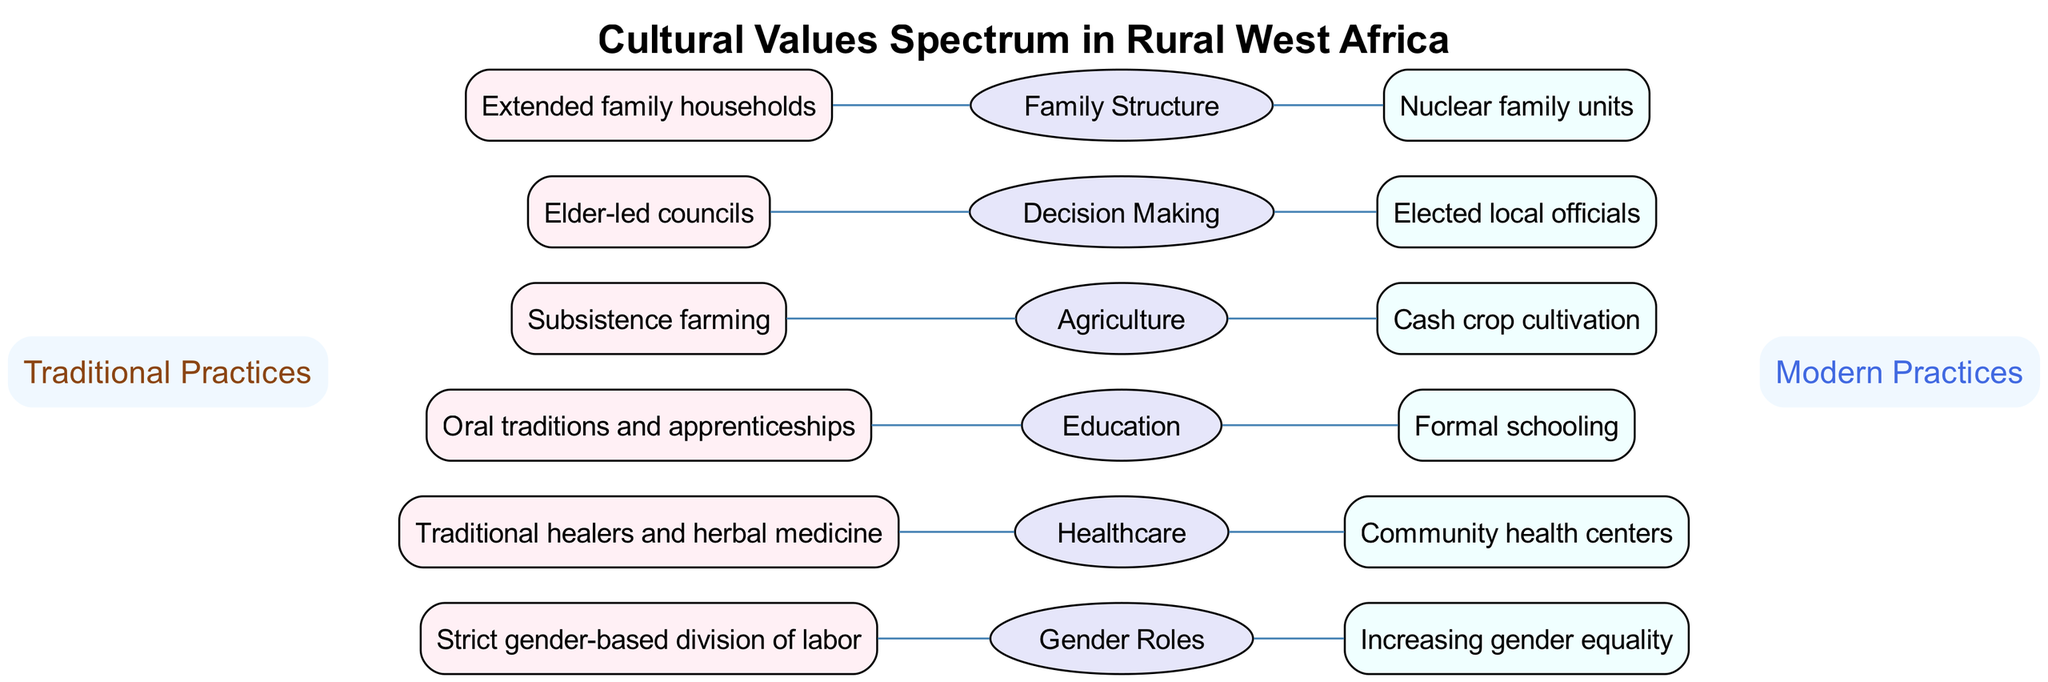What is the traditional family structure depicted in the diagram? The diagram states that the traditional family structure is "Extended family households." This information can be found in the category labeled "Family Structure," where the left side (traditional) gives this value.
Answer: Extended family households What is the modern practice for education according to the diagram? In the "Education" category of the diagram, it shows that the modern practice is "Formal schooling," which is indicated on the right side text for that specific category.
Answer: Formal schooling How many categories are present in the diagram? The diagram lists a total of six categories: "Family Structure," "Decision Making," "Agriculture," "Education," "Healthcare," and "Gender Roles." Counting these gives a total of six categories.
Answer: 6 Which decision-making practice is considered traditional? In the category labeled "Decision Making," the diagram indicates that the traditional practice is "Elder-led councils." This is found on the left side of that category.
Answer: Elder-led councils Which healthcare practice is modern in the diagram? The "Healthcare" category shows that the modern practice is "Community health centers." This information is located on the right side of the healthcare category in the diagram.
Answer: Community health centers What is the relationship between traditional healers and modern healthcare? Traditional healers are grouped with "Traditional healers and herbal medicine" in the "Healthcare" category, while "Community health centers" is positioned on the modern side. The relationship indicates a shift from traditional methods to modern healthcare solutions.
Answer: Shift from traditional to modern What is the main difference in gender roles expressed in the diagram? The diagram showcases a clear distinction: on the traditional side, it states "Strict gender-based division of labor," while the modern side represents "Increasing gender equality." This reflects a transition in gender roles over time.
Answer: Transition to gender equality Which type of decision-making is indicated to be modern? According to the diagram in the "Decision Making" category, the modern practice listed is "Elected local officials," appearing on the right side of the category.
Answer: Elected local officials What agricultural practice is characterized as traditional? The "Agriculture" category indicates that the traditional practice is "Subsistence farming," which can be found on the left side of this category within the diagram.
Answer: Subsistence farming 